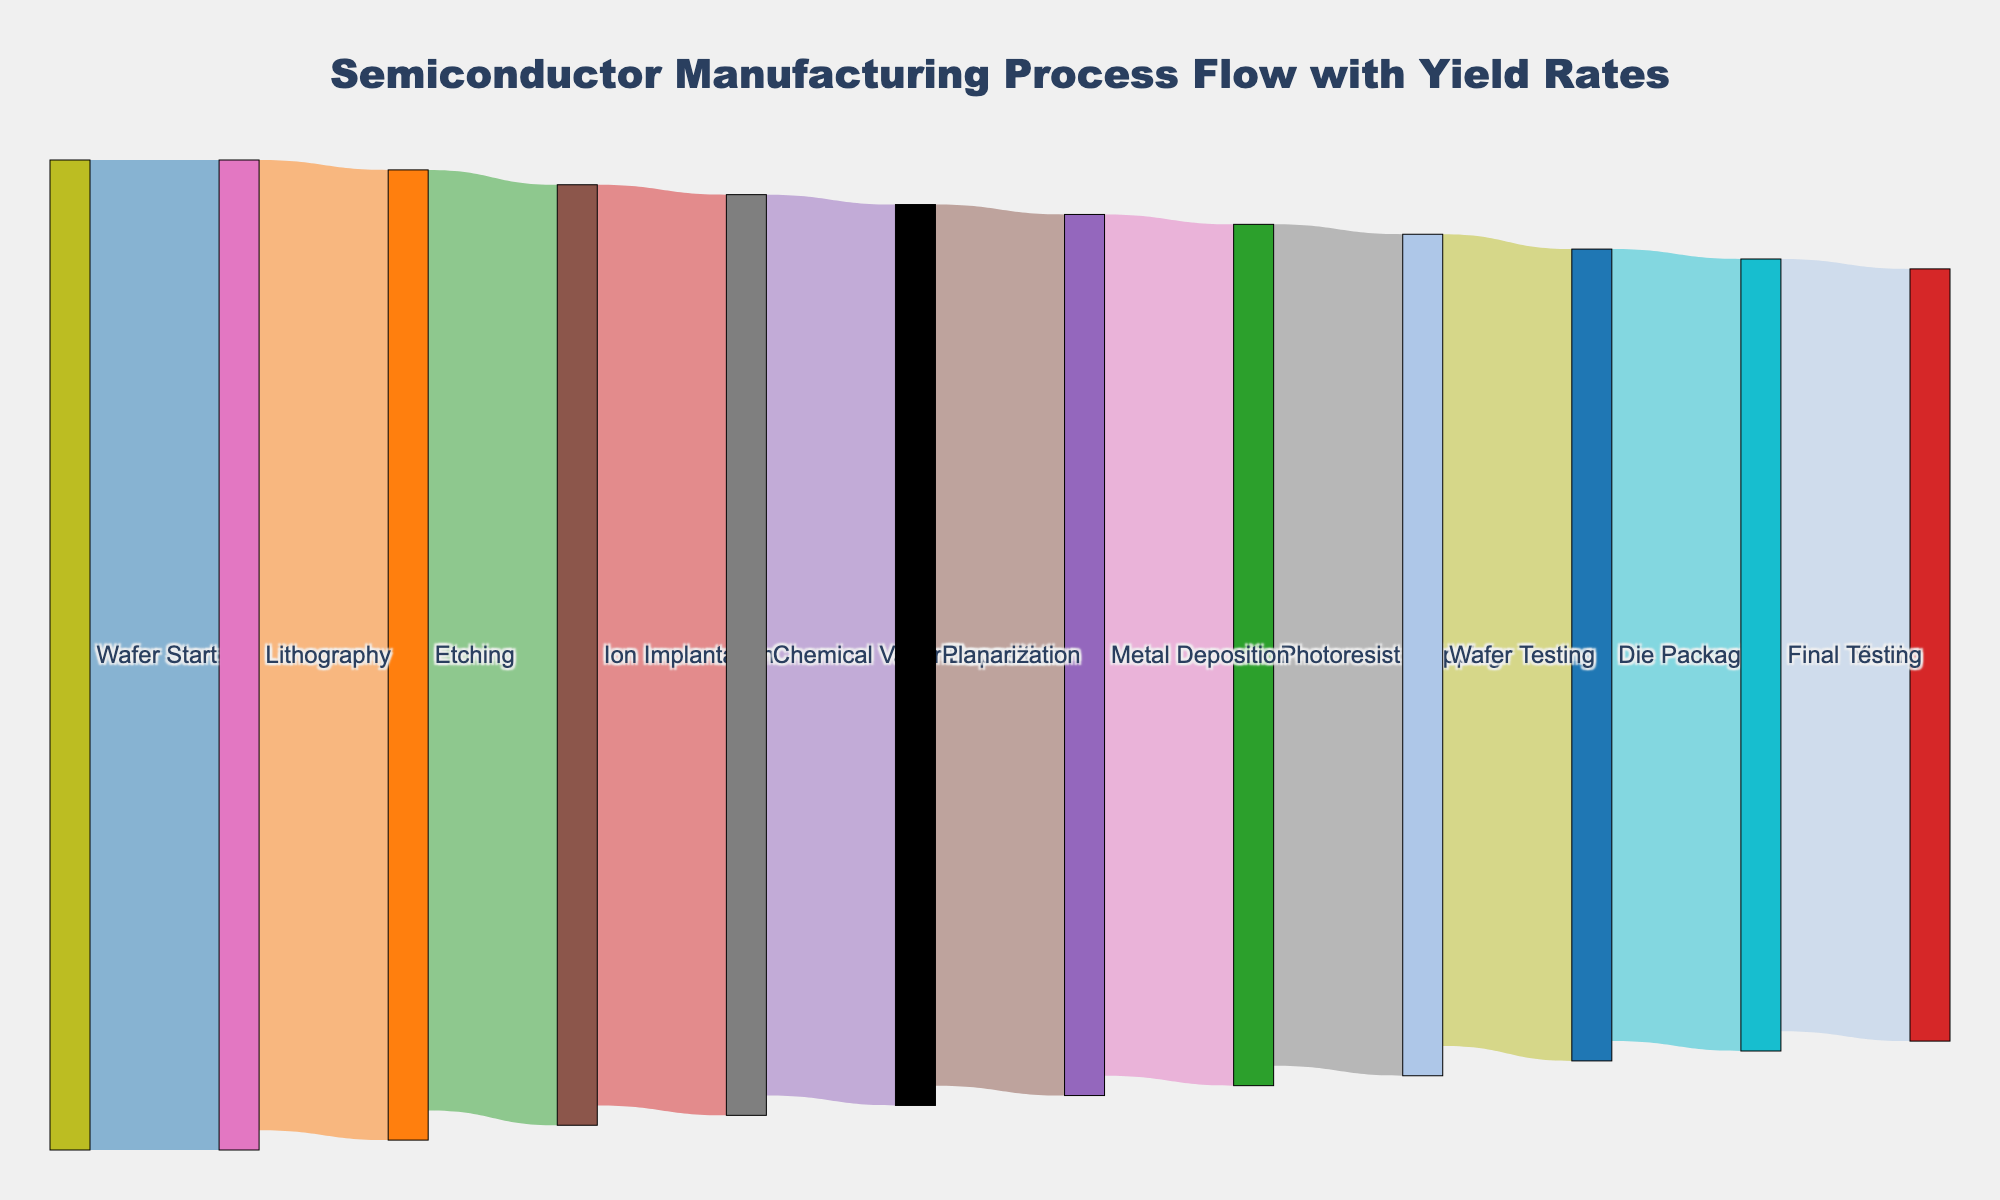What is the title of the figure? The title is located at the top of the figure, which provides a summary of what the Sankey diagram represents.
Answer: Semiconductor Manufacturing Process Flow with Yield Rates What are the first and last stages in the process flow? By following the sequence of the links from left to right, the first stage is "Wafer Start" and the last stage is "Yield."
Answer: Wafer Start, Yield How many stages in total are represented in the manufacturing process? Count the unique stages in both the source and target columns. They are Wafer Start, Lithography, Etching, Ion Implantation, Chemical Vapor Deposition, Planarization, Metal Deposition, Photoresist Stripping, Wafer Testing, Die Packaging, Final Testing, and Yield.
Answer: 12 What is the yield rate after the Ion Implantation stage? Identify the connection leading from Ion Implantation to the next stage, Chemical Vapor Deposition. The value associated with this connection indicates the yield rate after Ion Implantation.
Answer: 93 What is the drop in yield rate from the Lithography stage to the Etching stage? Compare the yield rate at the end of the Lithography stage (100) with the yield rate at the end of the Etching stage (98). Subtract the latter from the former to find the difference.
Answer: 2 What is the total yield loss from the Wafer Start to the Final Testing stage? Subtract the yield rate at the Final Testing stage (80) from the yield rate at the Wafer Start stage (100).
Answer: 20 Which stage has the lowest yield rate in the entire process? Look for the stage connected to the final target "Yield" and identify its value. The stage before "Yield" has the lowest yield rate shown in the diagram, which is "Final Testing" with a yield rate of 78.
Answer: Final Testing How does the yield rate change between Planarization and Metal Deposition? Examine the yield rate before and after the Planarization stage. The yield rate decreases from 91 to 89 between Planarization and Metal Deposition.
Answer: Decreases by 2 What is the average yield rate across all stages? Sum the yield rates after each stage (100, 98, 95, 93, 91, 89, 87, 85, 82, 80, 78) and divide by the number of stages (11) to find the average yield rate.
Answer: (100 + 98 + 95 + 93 + 91 + 89 + 87 + 85 + 82 + 80 + 78) / 11 = 88.64 Of the stages with yield rates listed below 90, which stage has the highest yield rate? Consider the stages with yield rates below 90: Metal Deposition (89), Photoresist Stripping (87), Wafer Testing (85), Die Packaging (82), Final Testing (80). The highest yield rate among them is for Metal Deposition at 89.
Answer: Metal Deposition 